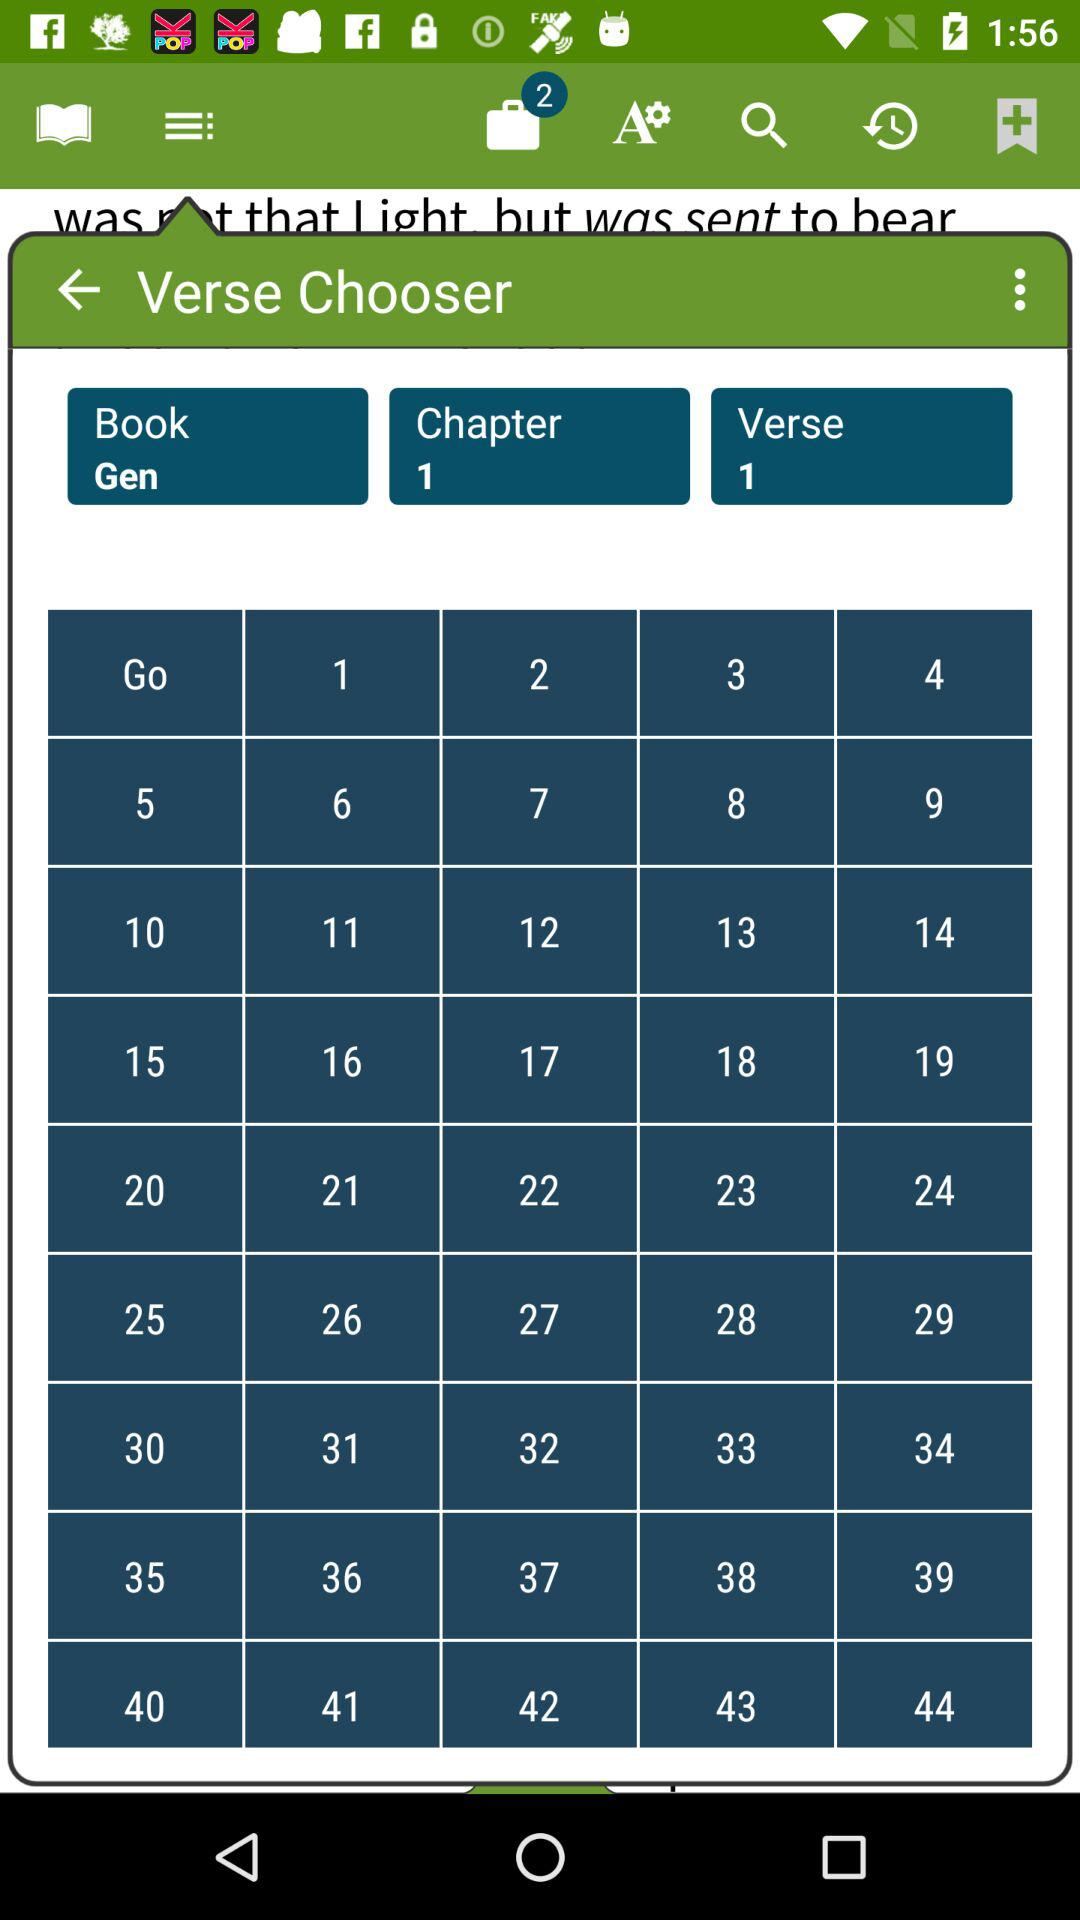What verse number is chosen? The chosen verse number is 1. 